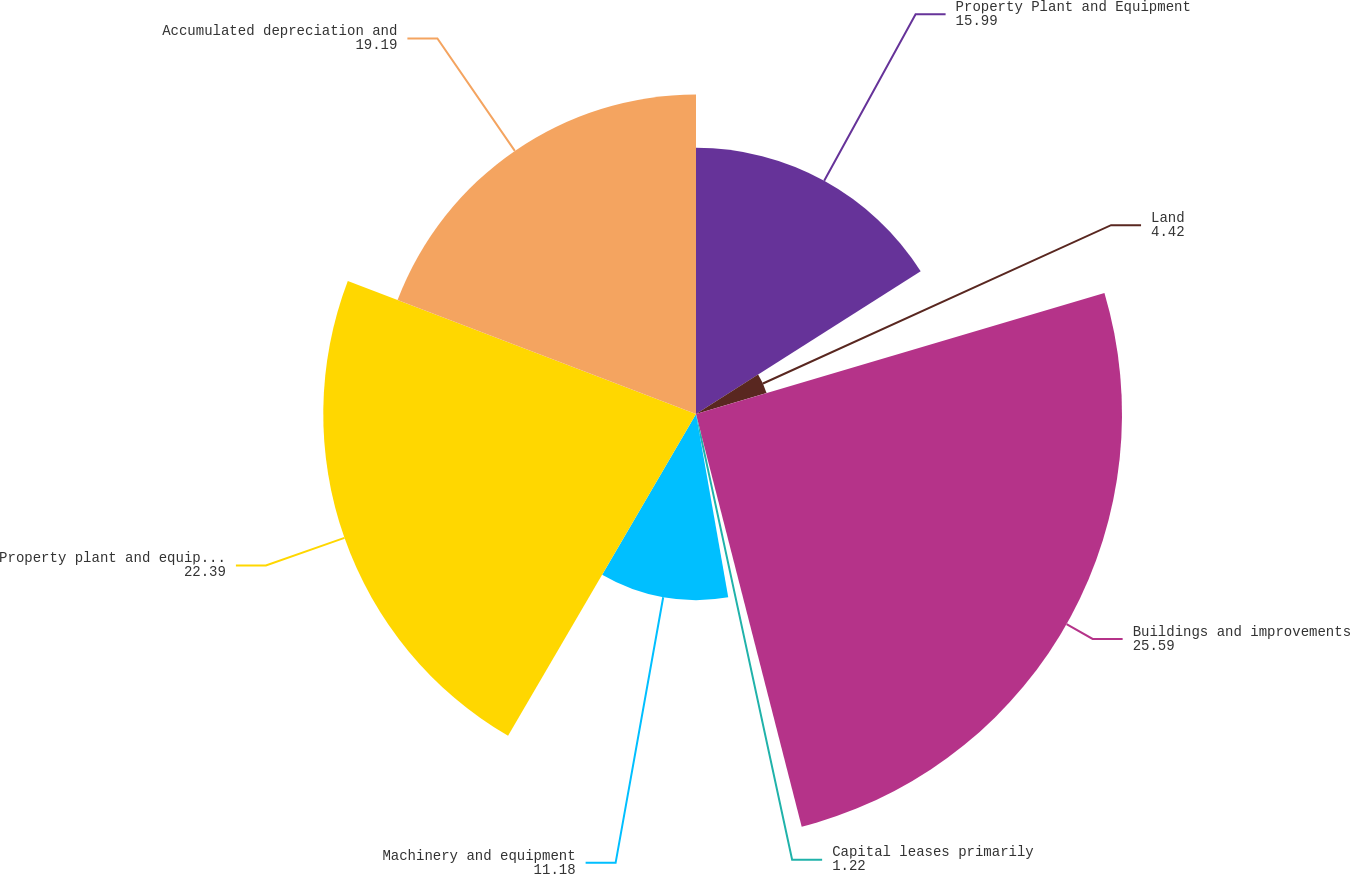Convert chart to OTSL. <chart><loc_0><loc_0><loc_500><loc_500><pie_chart><fcel>Property Plant and Equipment<fcel>Land<fcel>Buildings and improvements<fcel>Capital leases primarily<fcel>Machinery and equipment<fcel>Property plant and equipment<fcel>Accumulated depreciation and<nl><fcel>15.99%<fcel>4.42%<fcel>25.59%<fcel>1.22%<fcel>11.18%<fcel>22.39%<fcel>19.19%<nl></chart> 